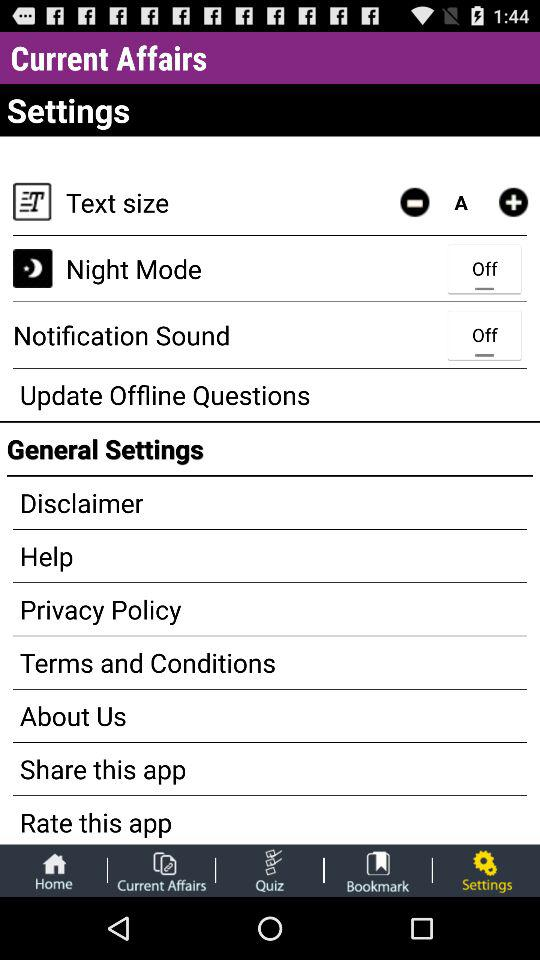Which tab is selected? The selected tab is "Settings". 